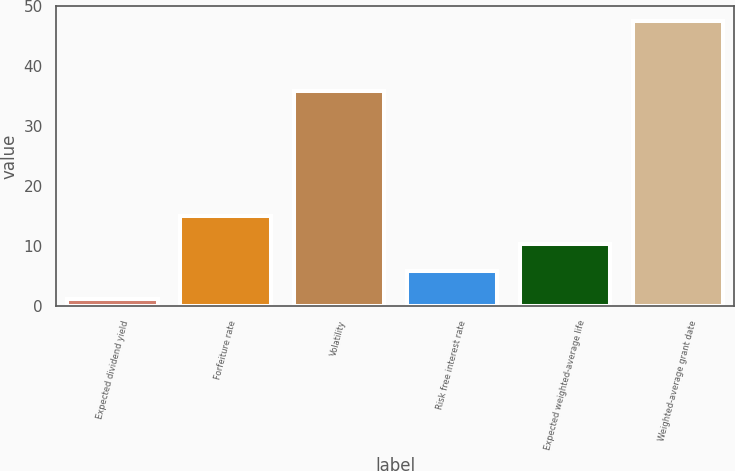<chart> <loc_0><loc_0><loc_500><loc_500><bar_chart><fcel>Expected dividend yield<fcel>Forfeiture rate<fcel>Volatility<fcel>Risk free interest rate<fcel>Expected weighted-average life<fcel>Weighted-average grant date<nl><fcel>1.14<fcel>15.09<fcel>35.93<fcel>5.79<fcel>10.44<fcel>47.63<nl></chart> 